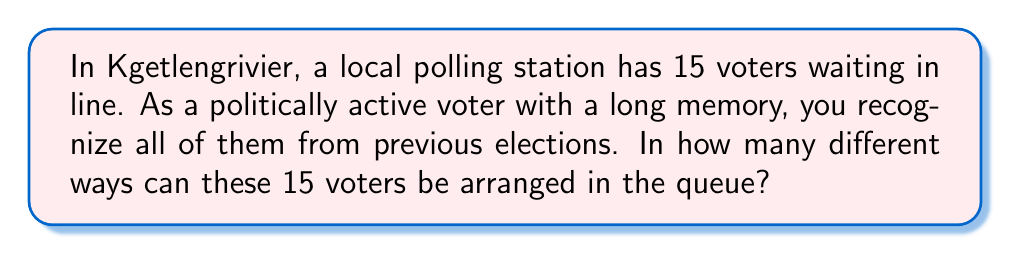Can you solve this math problem? Let's approach this step-by-step:

1) This is a permutation problem. We need to arrange 15 distinct voters in a line, where the order matters.

2) In permutation problems where all elements are distinct and all are used, we use the formula:

   $$P(n) = n!$$

   Where $n$ is the number of distinct elements.

3) In this case, $n = 15$ (the number of voters).

4) Therefore, the number of ways to arrange 15 voters is:

   $$P(15) = 15!$$

5) Let's calculate this:
   
   $$15! = 15 \times 14 \times 13 \times 12 \times 11 \times 10 \times 9 \times 8 \times 7 \times 6 \times 5 \times 4 \times 3 \times 2 \times 1$$

6) This equals:

   $$15! = 1,307,674,368,000$$

Thus, there are 1,307,674,368,000 different ways to arrange 15 voters in the polling station queue.
Answer: $15! = 1,307,674,368,000$ 